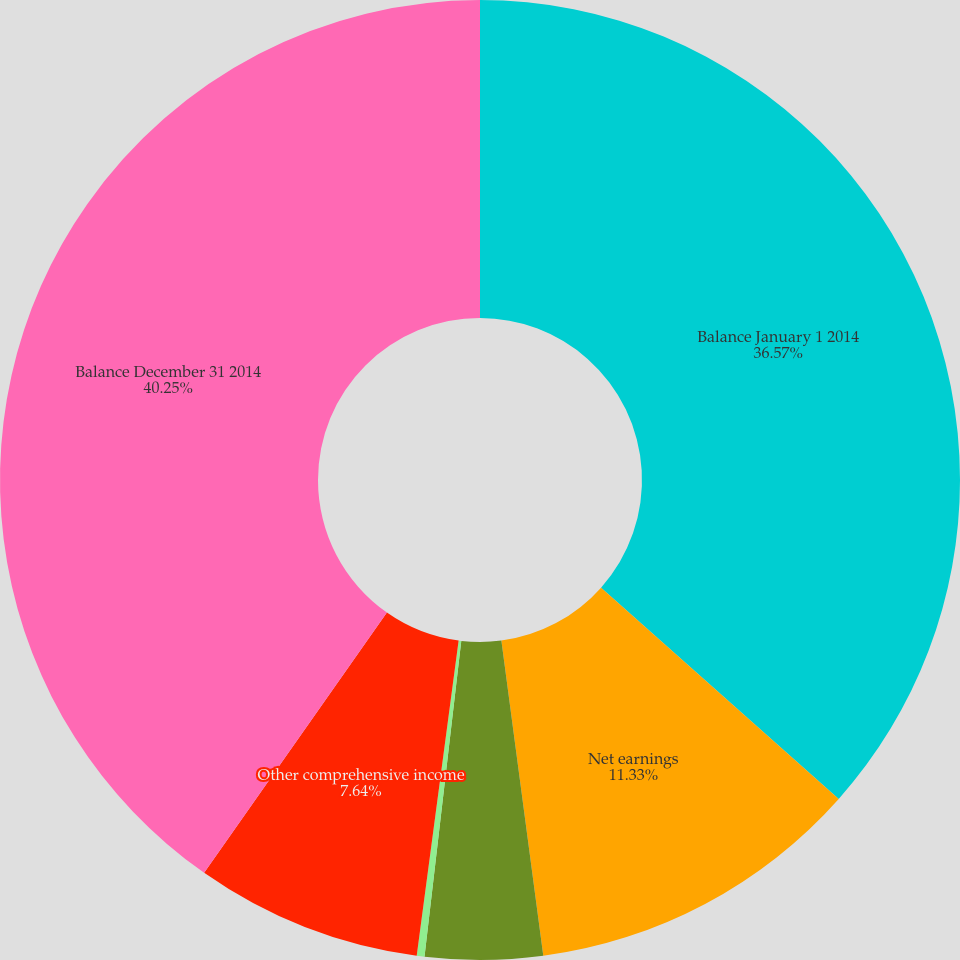Convert chart to OTSL. <chart><loc_0><loc_0><loc_500><loc_500><pie_chart><fcel>Balance January 1 2014<fcel>Net earnings<fcel>Purchase of treasury stock<fcel>Stock-based compensation<fcel>Other comprehensive income<fcel>Balance December 31 2014<nl><fcel>36.57%<fcel>11.33%<fcel>3.95%<fcel>0.26%<fcel>7.64%<fcel>40.26%<nl></chart> 